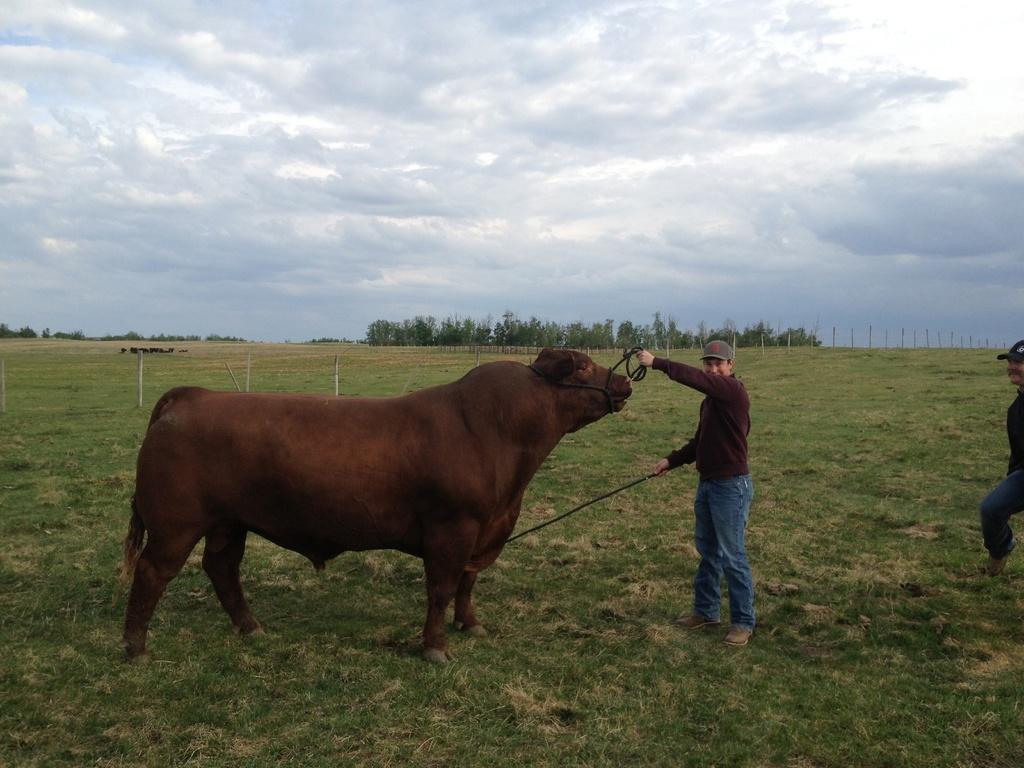What type of animal is in the image? There is an animal in the image, but the specific type cannot be determined from the provided facts. What are the people on the ground doing in the image? The actions of the people on the ground cannot be determined from the provided facts. What can be seen in the background of the image? In the background of the image, there are poles, trees, and the sky. What is the condition of the sky in the image? The sky is visible in the background of the image, and clouds are present. How many crayons are being used by the birds in the image? There are no birds or crayons present in the image. 